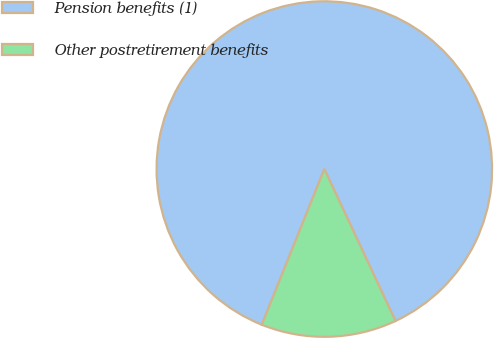Convert chart to OTSL. <chart><loc_0><loc_0><loc_500><loc_500><pie_chart><fcel>Pension benefits (1)<fcel>Other postretirement benefits<nl><fcel>86.95%<fcel>13.05%<nl></chart> 